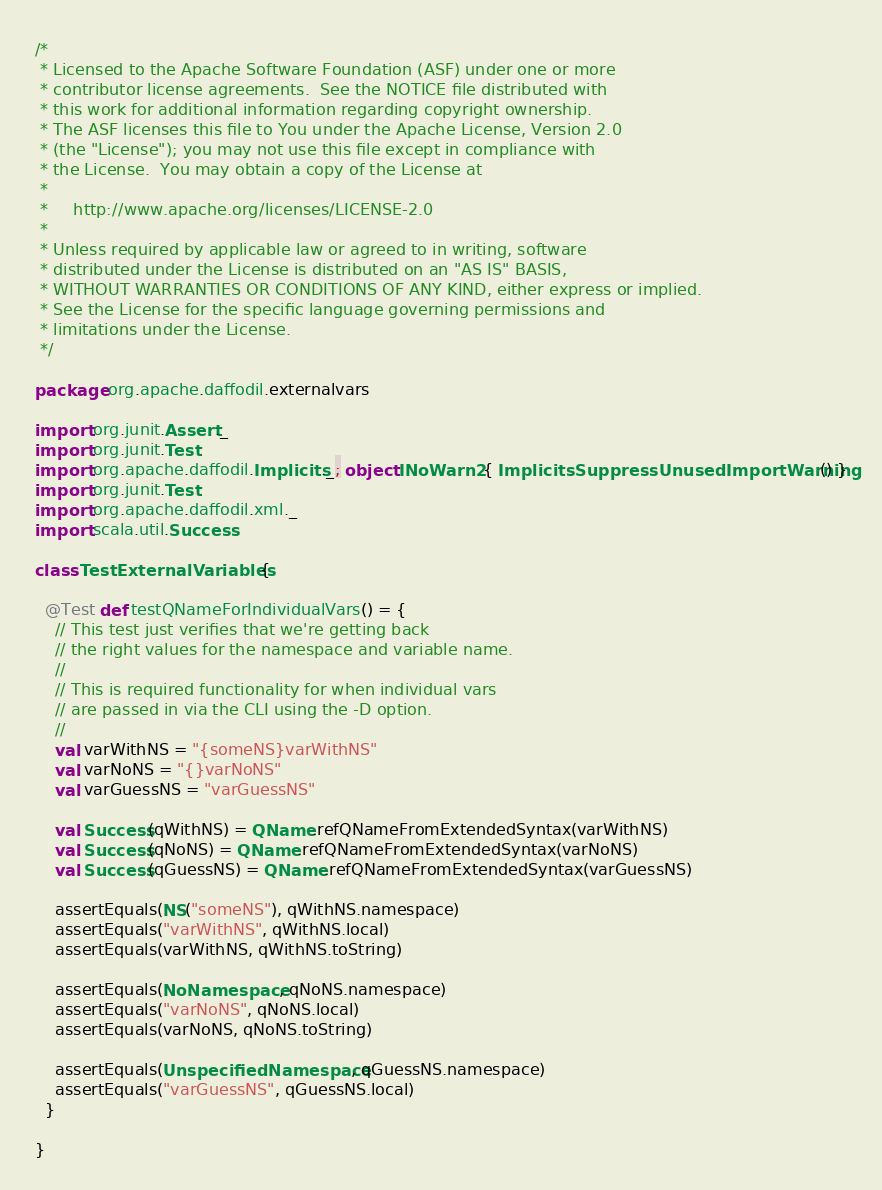<code> <loc_0><loc_0><loc_500><loc_500><_Scala_>/*
 * Licensed to the Apache Software Foundation (ASF) under one or more
 * contributor license agreements.  See the NOTICE file distributed with
 * this work for additional information regarding copyright ownership.
 * The ASF licenses this file to You under the Apache License, Version 2.0
 * (the "License"); you may not use this file except in compliance with
 * the License.  You may obtain a copy of the License at
 *
 *     http://www.apache.org/licenses/LICENSE-2.0
 *
 * Unless required by applicable law or agreed to in writing, software
 * distributed under the License is distributed on an "AS IS" BASIS,
 * WITHOUT WARRANTIES OR CONDITIONS OF ANY KIND, either express or implied.
 * See the License for the specific language governing permissions and
 * limitations under the License.
 */

package org.apache.daffodil.externalvars

import org.junit.Assert._
import org.junit.Test
import org.apache.daffodil.Implicits._; object INoWarn2 { ImplicitsSuppressUnusedImportWarning() }
import org.junit.Test
import org.apache.daffodil.xml._
import scala.util.Success

class TestExternalVariables {

  @Test def testQNameForIndividualVars() = {
    // This test just verifies that we're getting back
    // the right values for the namespace and variable name.
    //
    // This is required functionality for when individual vars
    // are passed in via the CLI using the -D option.
    //
    val varWithNS = "{someNS}varWithNS"
    val varNoNS = "{}varNoNS"
    val varGuessNS = "varGuessNS"

    val Success(qWithNS) = QName.refQNameFromExtendedSyntax(varWithNS)
    val Success(qNoNS) = QName.refQNameFromExtendedSyntax(varNoNS)
    val Success(qGuessNS) = QName.refQNameFromExtendedSyntax(varGuessNS)

    assertEquals(NS("someNS"), qWithNS.namespace)
    assertEquals("varWithNS", qWithNS.local)
    assertEquals(varWithNS, qWithNS.toString)

    assertEquals(NoNamespace, qNoNS.namespace)
    assertEquals("varNoNS", qNoNS.local)
    assertEquals(varNoNS, qNoNS.toString)

    assertEquals(UnspecifiedNamespace, qGuessNS.namespace)
    assertEquals("varGuessNS", qGuessNS.local)
  }

}
</code> 